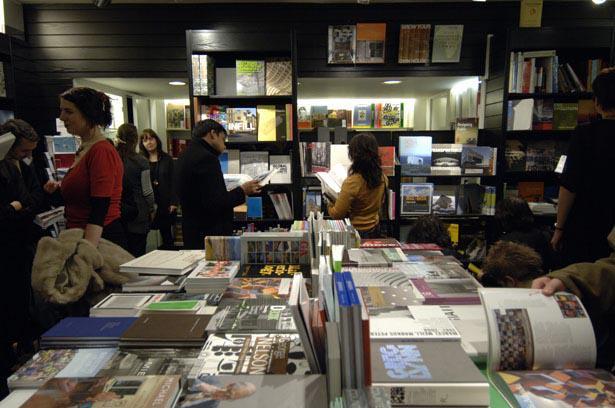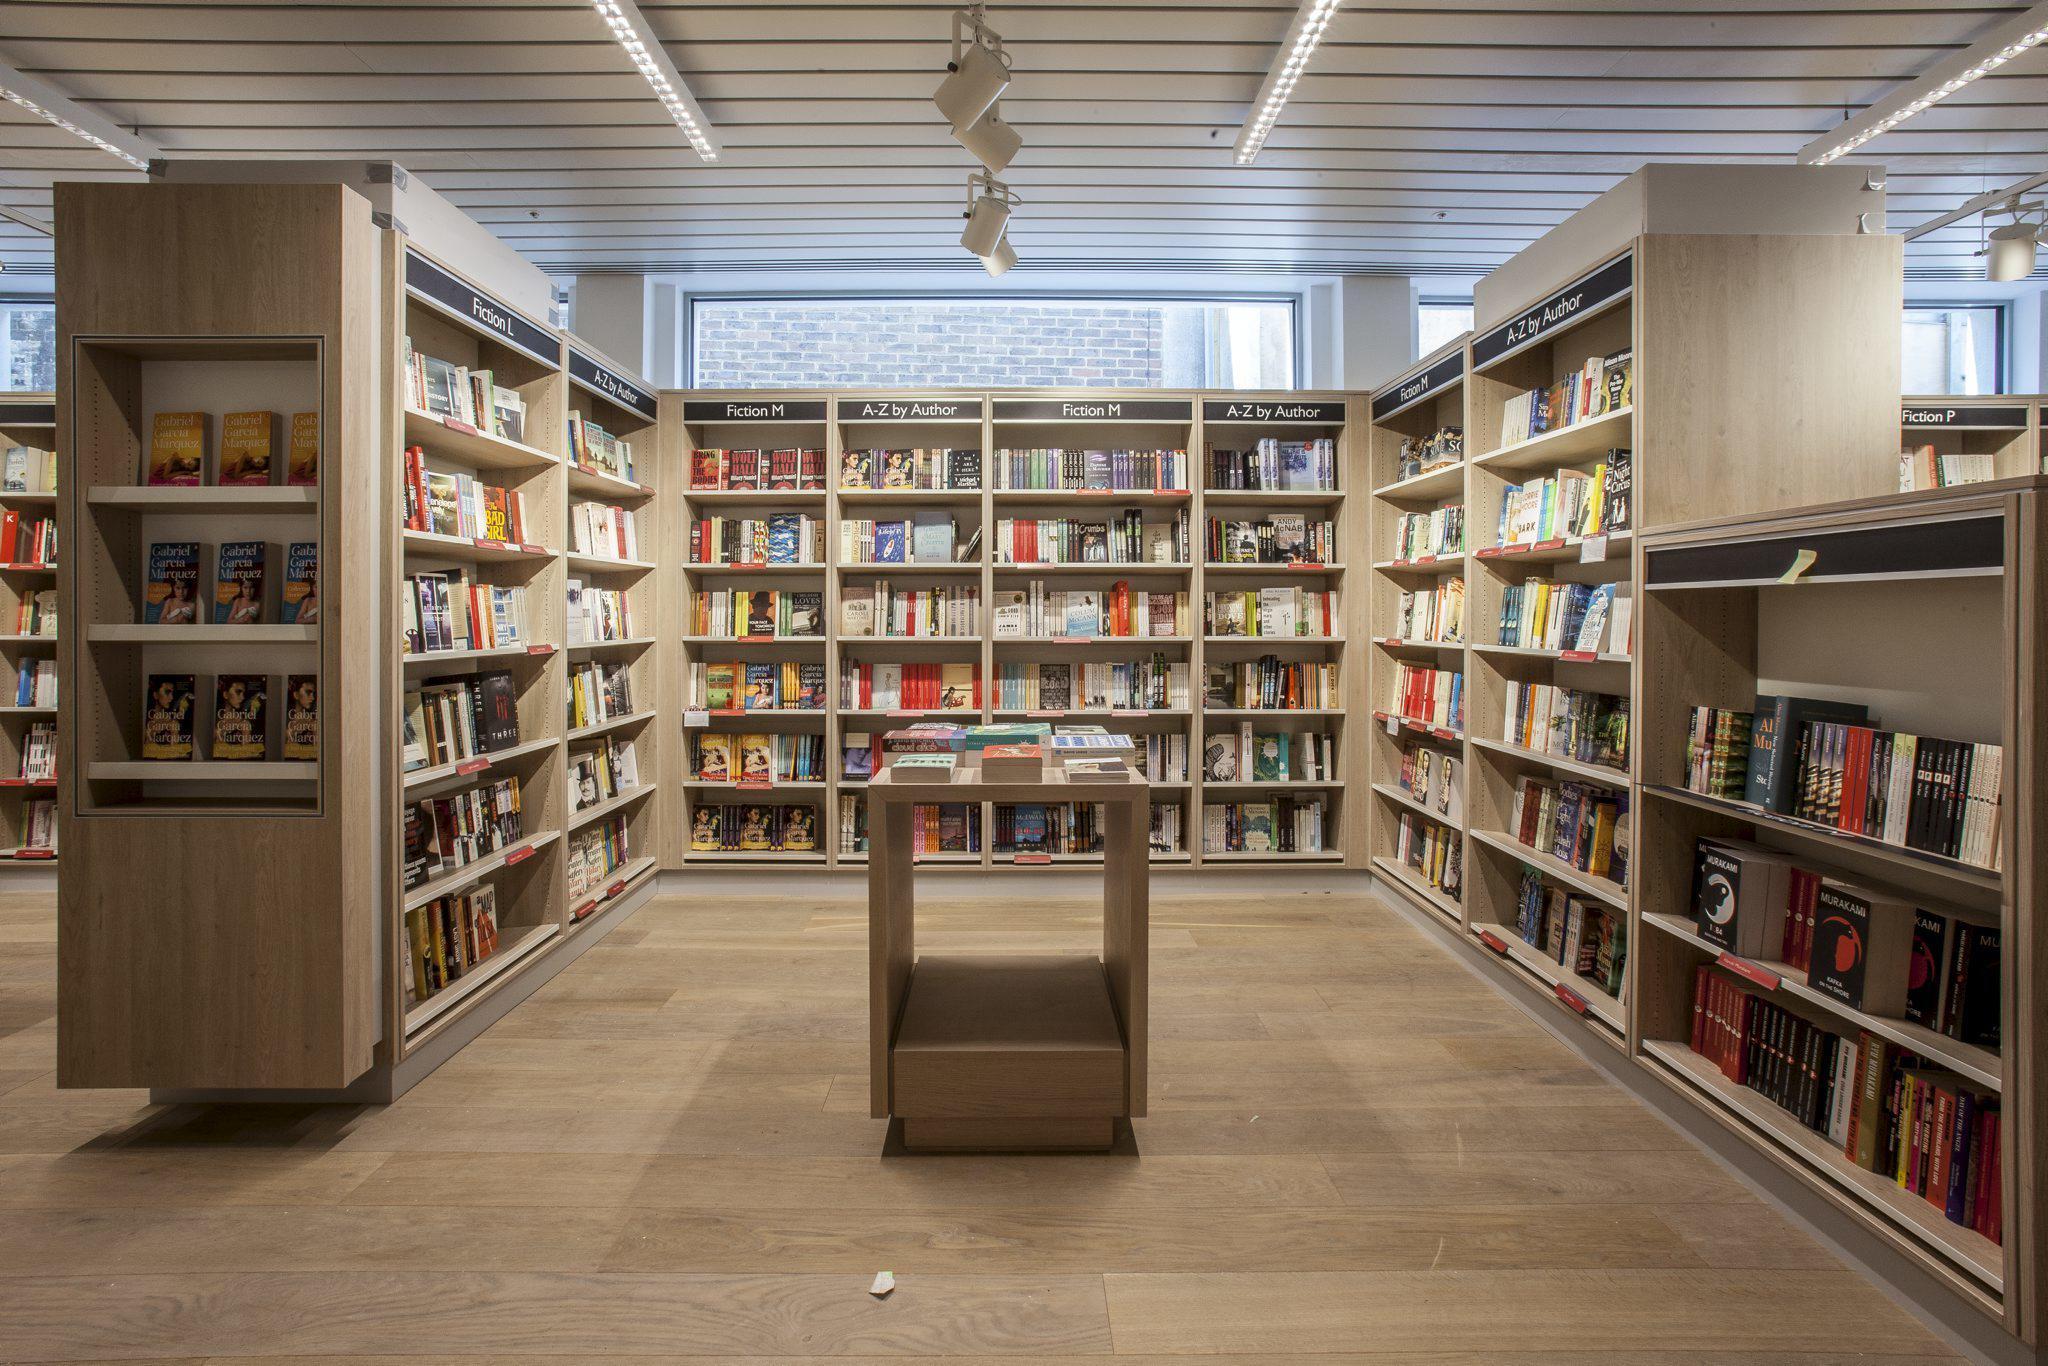The first image is the image on the left, the second image is the image on the right. Considering the images on both sides, is "In one of the images there is a bookstore without any shoppers." valid? Answer yes or no. Yes. 